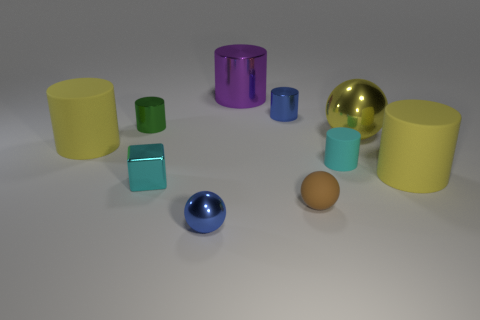If these objects were part of a game, what kind of game could it be and what rules would you suggest? If these objects were part of a game, it could be a sorting or categorization game. The rules might involve organizing the objects by color, size, or material within a time limit, and points could be awarded for the accuracy and speed of the sorting.  Are there any patterns or arrangements in how the objects are positioned? The objects appear to be randomly positioned with no immediate discernible pattern. However, objects of similar shapes are close to each other, which could suggest a loose arrangement by shape or type. 